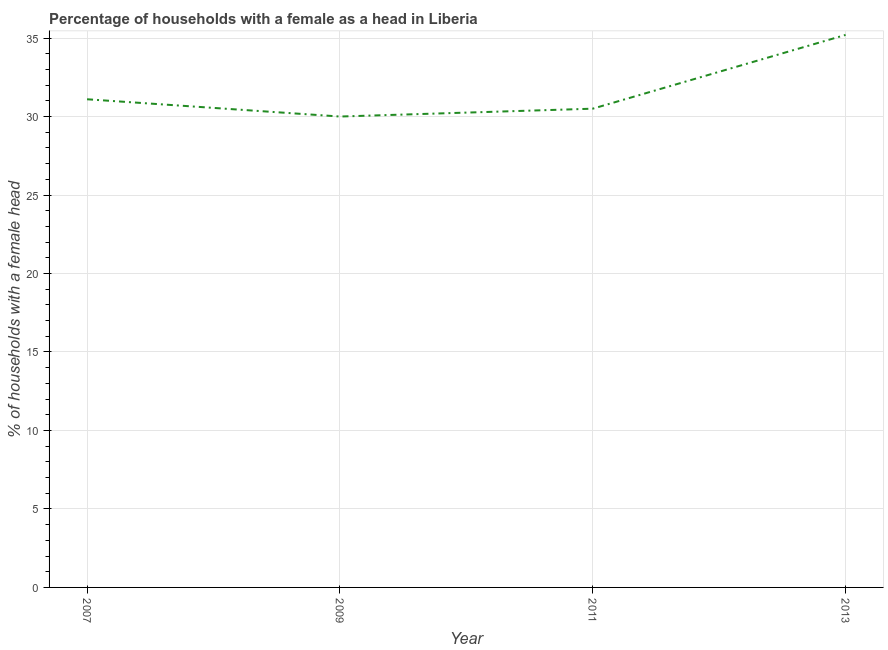What is the number of female supervised households in 2007?
Offer a terse response. 31.1. Across all years, what is the maximum number of female supervised households?
Your response must be concise. 35.2. In which year was the number of female supervised households minimum?
Your answer should be very brief. 2009. What is the sum of the number of female supervised households?
Give a very brief answer. 126.8. What is the difference between the number of female supervised households in 2011 and 2013?
Ensure brevity in your answer.  -4.7. What is the average number of female supervised households per year?
Keep it short and to the point. 31.7. What is the median number of female supervised households?
Offer a very short reply. 30.8. What is the ratio of the number of female supervised households in 2007 to that in 2013?
Your response must be concise. 0.88. What is the difference between the highest and the second highest number of female supervised households?
Your answer should be very brief. 4.1. What is the difference between the highest and the lowest number of female supervised households?
Make the answer very short. 5.2. How many lines are there?
Give a very brief answer. 1. How many years are there in the graph?
Provide a succinct answer. 4. Does the graph contain any zero values?
Keep it short and to the point. No. Does the graph contain grids?
Offer a terse response. Yes. What is the title of the graph?
Provide a short and direct response. Percentage of households with a female as a head in Liberia. What is the label or title of the Y-axis?
Your answer should be very brief. % of households with a female head. What is the % of households with a female head of 2007?
Ensure brevity in your answer.  31.1. What is the % of households with a female head in 2009?
Make the answer very short. 30. What is the % of households with a female head in 2011?
Offer a terse response. 30.5. What is the % of households with a female head of 2013?
Offer a very short reply. 35.2. What is the difference between the % of households with a female head in 2007 and 2009?
Your answer should be compact. 1.1. What is the difference between the % of households with a female head in 2007 and 2011?
Give a very brief answer. 0.6. What is the difference between the % of households with a female head in 2009 and 2013?
Provide a short and direct response. -5.2. What is the difference between the % of households with a female head in 2011 and 2013?
Make the answer very short. -4.7. What is the ratio of the % of households with a female head in 2007 to that in 2013?
Your answer should be very brief. 0.88. What is the ratio of the % of households with a female head in 2009 to that in 2011?
Your answer should be compact. 0.98. What is the ratio of the % of households with a female head in 2009 to that in 2013?
Your response must be concise. 0.85. What is the ratio of the % of households with a female head in 2011 to that in 2013?
Provide a short and direct response. 0.87. 